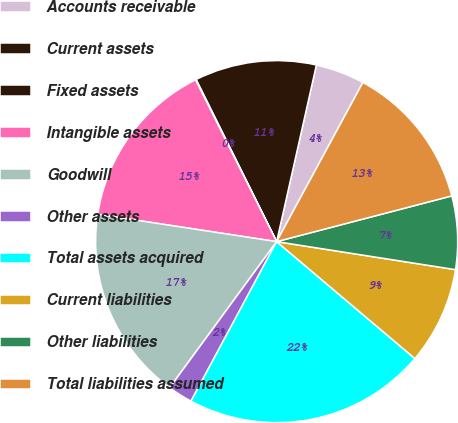<chart> <loc_0><loc_0><loc_500><loc_500><pie_chart><fcel>Accounts receivable<fcel>Current assets<fcel>Fixed assets<fcel>Intangible assets<fcel>Goodwill<fcel>Other assets<fcel>Total assets acquired<fcel>Current liabilities<fcel>Other liabilities<fcel>Total liabilities assumed<nl><fcel>4.38%<fcel>10.86%<fcel>0.06%<fcel>15.19%<fcel>17.35%<fcel>2.22%<fcel>21.67%<fcel>8.7%<fcel>6.54%<fcel>13.03%<nl></chart> 